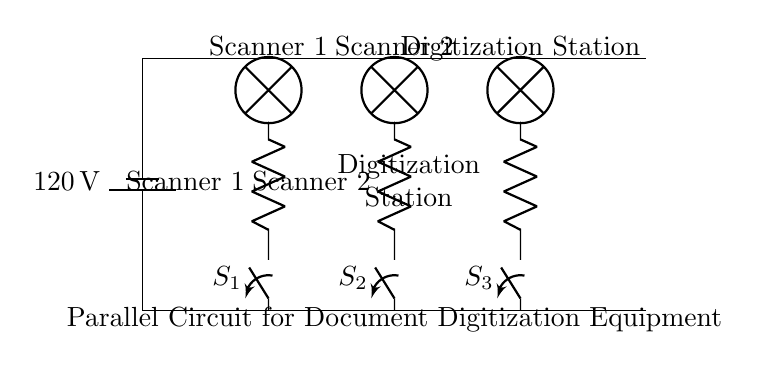What is the voltage of this circuit? The voltage is 120 volts, which can be found at the battery symbol indicating the power source of the circuit.
Answer: 120 volts What components are connected in parallel? The components connected in parallel are Scanner 1, Scanner 2, and the Digitization Station, as indicated by the separate branches stemming from the main power lines.
Answer: Scanner 1, Scanner 2, Digitization Station How many switches are used in the circuit? There are three switches indicated by the symbols labeled S1, S2, and S3; each switch controls one of the scanning devices or the digitization station.
Answer: Three What is the function of each switch? Each switch allows for the individual control of power to its respective device: S1 for Scanner 1, S2 for Scanner 2, and S3 for the Digitization Station.
Answer: Control power to devices What type of circuit is represented in the diagram? The circuit is a parallel circuit as it has multiple branches connecting to the same voltage source, allowing current to flow through each branch independently.
Answer: Parallel circuit Which device has the longest connection to the power source? The connection for the Digitization Station is the longest as it is positioned furthest from the power source.
Answer: Digitization Station 